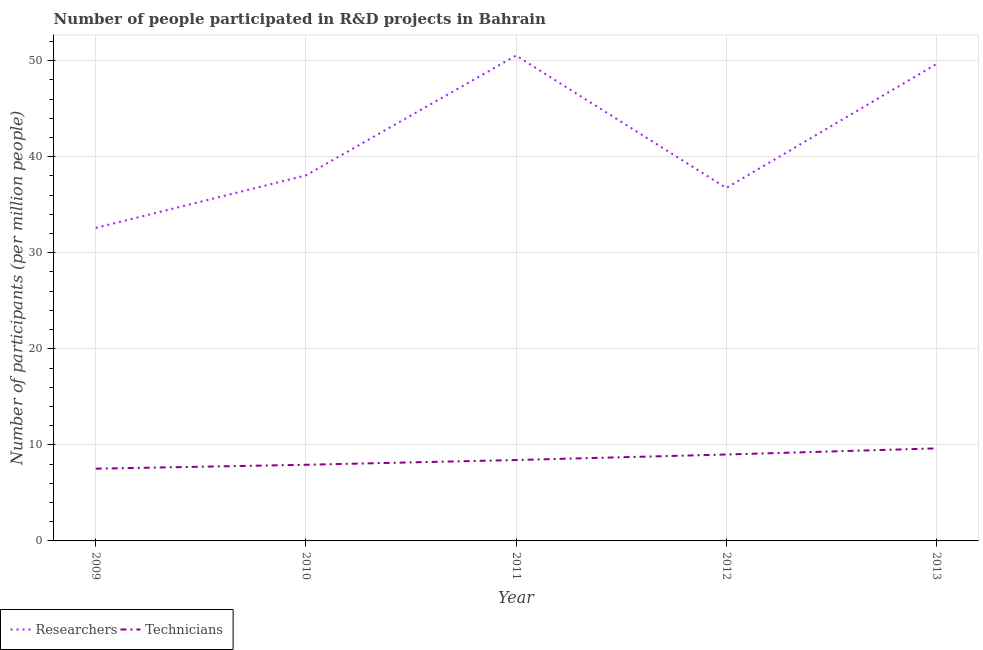How many different coloured lines are there?
Keep it short and to the point. 2. Is the number of lines equal to the number of legend labels?
Offer a very short reply. Yes. What is the number of researchers in 2011?
Keep it short and to the point. 50.54. Across all years, what is the maximum number of researchers?
Offer a terse response. 50.54. Across all years, what is the minimum number of researchers?
Make the answer very short. 32.59. What is the total number of researchers in the graph?
Keep it short and to the point. 207.57. What is the difference between the number of technicians in 2009 and that in 2011?
Provide a succinct answer. -0.9. What is the difference between the number of researchers in 2010 and the number of technicians in 2009?
Your answer should be compact. 30.54. What is the average number of technicians per year?
Offer a very short reply. 8.5. In the year 2013, what is the difference between the number of researchers and number of technicians?
Your answer should be compact. 40.02. In how many years, is the number of technicians greater than 40?
Offer a terse response. 0. What is the ratio of the number of researchers in 2009 to that in 2011?
Ensure brevity in your answer.  0.64. Is the difference between the number of technicians in 2009 and 2012 greater than the difference between the number of researchers in 2009 and 2012?
Offer a very short reply. Yes. What is the difference between the highest and the second highest number of technicians?
Provide a short and direct response. 0.64. What is the difference between the highest and the lowest number of researchers?
Provide a succinct answer. 17.95. In how many years, is the number of technicians greater than the average number of technicians taken over all years?
Your response must be concise. 2. Does the number of researchers monotonically increase over the years?
Provide a short and direct response. No. Is the number of researchers strictly greater than the number of technicians over the years?
Provide a short and direct response. Yes. Is the number of researchers strictly less than the number of technicians over the years?
Provide a succinct answer. No. What is the difference between two consecutive major ticks on the Y-axis?
Your answer should be very brief. 10. Are the values on the major ticks of Y-axis written in scientific E-notation?
Provide a succinct answer. No. Does the graph contain any zero values?
Provide a succinct answer. No. Does the graph contain grids?
Your answer should be compact. Yes. How are the legend labels stacked?
Make the answer very short. Horizontal. What is the title of the graph?
Offer a terse response. Number of people participated in R&D projects in Bahrain. Does "Goods" appear as one of the legend labels in the graph?
Your response must be concise. No. What is the label or title of the Y-axis?
Give a very brief answer. Number of participants (per million people). What is the Number of participants (per million people) of Researchers in 2009?
Provide a succinct answer. 32.59. What is the Number of participants (per million people) of Technicians in 2009?
Provide a short and direct response. 7.52. What is the Number of participants (per million people) of Researchers in 2010?
Ensure brevity in your answer.  38.06. What is the Number of participants (per million people) in Technicians in 2010?
Give a very brief answer. 7.93. What is the Number of participants (per million people) in Researchers in 2011?
Offer a very short reply. 50.54. What is the Number of participants (per million people) in Technicians in 2011?
Make the answer very short. 8.42. What is the Number of participants (per million people) of Researchers in 2012?
Offer a terse response. 36.74. What is the Number of participants (per million people) in Technicians in 2012?
Your response must be concise. 9. What is the Number of participants (per million people) in Researchers in 2013?
Ensure brevity in your answer.  49.65. What is the Number of participants (per million people) in Technicians in 2013?
Your response must be concise. 9.63. Across all years, what is the maximum Number of participants (per million people) in Researchers?
Give a very brief answer. 50.54. Across all years, what is the maximum Number of participants (per million people) in Technicians?
Provide a succinct answer. 9.63. Across all years, what is the minimum Number of participants (per million people) of Researchers?
Provide a short and direct response. 32.59. Across all years, what is the minimum Number of participants (per million people) in Technicians?
Provide a succinct answer. 7.52. What is the total Number of participants (per million people) of Researchers in the graph?
Your answer should be very brief. 207.57. What is the total Number of participants (per million people) in Technicians in the graph?
Your response must be concise. 42.5. What is the difference between the Number of participants (per million people) of Researchers in 2009 and that in 2010?
Ensure brevity in your answer.  -5.47. What is the difference between the Number of participants (per million people) of Technicians in 2009 and that in 2010?
Keep it short and to the point. -0.41. What is the difference between the Number of participants (per million people) of Researchers in 2009 and that in 2011?
Your answer should be very brief. -17.95. What is the difference between the Number of participants (per million people) in Technicians in 2009 and that in 2011?
Provide a short and direct response. -0.9. What is the difference between the Number of participants (per million people) in Researchers in 2009 and that in 2012?
Provide a succinct answer. -4.16. What is the difference between the Number of participants (per million people) in Technicians in 2009 and that in 2012?
Give a very brief answer. -1.48. What is the difference between the Number of participants (per million people) of Researchers in 2009 and that in 2013?
Ensure brevity in your answer.  -17.06. What is the difference between the Number of participants (per million people) of Technicians in 2009 and that in 2013?
Your answer should be compact. -2.11. What is the difference between the Number of participants (per million people) of Researchers in 2010 and that in 2011?
Give a very brief answer. -12.48. What is the difference between the Number of participants (per million people) of Technicians in 2010 and that in 2011?
Your response must be concise. -0.49. What is the difference between the Number of participants (per million people) of Researchers in 2010 and that in 2012?
Provide a succinct answer. 1.31. What is the difference between the Number of participants (per million people) of Technicians in 2010 and that in 2012?
Your response must be concise. -1.07. What is the difference between the Number of participants (per million people) in Researchers in 2010 and that in 2013?
Your response must be concise. -11.6. What is the difference between the Number of participants (per million people) of Technicians in 2010 and that in 2013?
Make the answer very short. -1.71. What is the difference between the Number of participants (per million people) of Researchers in 2011 and that in 2012?
Your answer should be compact. 13.79. What is the difference between the Number of participants (per million people) of Technicians in 2011 and that in 2012?
Make the answer very short. -0.58. What is the difference between the Number of participants (per million people) in Researchers in 2011 and that in 2013?
Your response must be concise. 0.88. What is the difference between the Number of participants (per million people) in Technicians in 2011 and that in 2013?
Give a very brief answer. -1.21. What is the difference between the Number of participants (per million people) of Researchers in 2012 and that in 2013?
Provide a short and direct response. -12.91. What is the difference between the Number of participants (per million people) in Technicians in 2012 and that in 2013?
Provide a short and direct response. -0.64. What is the difference between the Number of participants (per million people) of Researchers in 2009 and the Number of participants (per million people) of Technicians in 2010?
Your answer should be very brief. 24.66. What is the difference between the Number of participants (per million people) of Researchers in 2009 and the Number of participants (per million people) of Technicians in 2011?
Give a very brief answer. 24.16. What is the difference between the Number of participants (per million people) of Researchers in 2009 and the Number of participants (per million people) of Technicians in 2012?
Make the answer very short. 23.59. What is the difference between the Number of participants (per million people) of Researchers in 2009 and the Number of participants (per million people) of Technicians in 2013?
Your answer should be compact. 22.95. What is the difference between the Number of participants (per million people) in Researchers in 2010 and the Number of participants (per million people) in Technicians in 2011?
Give a very brief answer. 29.63. What is the difference between the Number of participants (per million people) of Researchers in 2010 and the Number of participants (per million people) of Technicians in 2012?
Provide a succinct answer. 29.06. What is the difference between the Number of participants (per million people) in Researchers in 2010 and the Number of participants (per million people) in Technicians in 2013?
Provide a succinct answer. 28.42. What is the difference between the Number of participants (per million people) in Researchers in 2011 and the Number of participants (per million people) in Technicians in 2012?
Your answer should be very brief. 41.54. What is the difference between the Number of participants (per million people) in Researchers in 2011 and the Number of participants (per million people) in Technicians in 2013?
Your response must be concise. 40.9. What is the difference between the Number of participants (per million people) of Researchers in 2012 and the Number of participants (per million people) of Technicians in 2013?
Your response must be concise. 27.11. What is the average Number of participants (per million people) of Researchers per year?
Offer a terse response. 41.51. What is the average Number of participants (per million people) in Technicians per year?
Keep it short and to the point. 8.5. In the year 2009, what is the difference between the Number of participants (per million people) in Researchers and Number of participants (per million people) in Technicians?
Provide a short and direct response. 25.07. In the year 2010, what is the difference between the Number of participants (per million people) of Researchers and Number of participants (per million people) of Technicians?
Your answer should be very brief. 30.13. In the year 2011, what is the difference between the Number of participants (per million people) in Researchers and Number of participants (per million people) in Technicians?
Provide a short and direct response. 42.11. In the year 2012, what is the difference between the Number of participants (per million people) of Researchers and Number of participants (per million people) of Technicians?
Your response must be concise. 27.74. In the year 2013, what is the difference between the Number of participants (per million people) of Researchers and Number of participants (per million people) of Technicians?
Keep it short and to the point. 40.02. What is the ratio of the Number of participants (per million people) of Researchers in 2009 to that in 2010?
Offer a terse response. 0.86. What is the ratio of the Number of participants (per million people) in Technicians in 2009 to that in 2010?
Your answer should be very brief. 0.95. What is the ratio of the Number of participants (per million people) of Researchers in 2009 to that in 2011?
Keep it short and to the point. 0.64. What is the ratio of the Number of participants (per million people) in Technicians in 2009 to that in 2011?
Offer a terse response. 0.89. What is the ratio of the Number of participants (per million people) of Researchers in 2009 to that in 2012?
Your answer should be very brief. 0.89. What is the ratio of the Number of participants (per million people) in Technicians in 2009 to that in 2012?
Your response must be concise. 0.84. What is the ratio of the Number of participants (per million people) of Researchers in 2009 to that in 2013?
Your answer should be very brief. 0.66. What is the ratio of the Number of participants (per million people) in Technicians in 2009 to that in 2013?
Provide a short and direct response. 0.78. What is the ratio of the Number of participants (per million people) of Researchers in 2010 to that in 2011?
Your answer should be compact. 0.75. What is the ratio of the Number of participants (per million people) of Technicians in 2010 to that in 2011?
Offer a terse response. 0.94. What is the ratio of the Number of participants (per million people) of Researchers in 2010 to that in 2012?
Give a very brief answer. 1.04. What is the ratio of the Number of participants (per million people) of Technicians in 2010 to that in 2012?
Keep it short and to the point. 0.88. What is the ratio of the Number of participants (per million people) in Researchers in 2010 to that in 2013?
Give a very brief answer. 0.77. What is the ratio of the Number of participants (per million people) of Technicians in 2010 to that in 2013?
Give a very brief answer. 0.82. What is the ratio of the Number of participants (per million people) of Researchers in 2011 to that in 2012?
Ensure brevity in your answer.  1.38. What is the ratio of the Number of participants (per million people) of Technicians in 2011 to that in 2012?
Offer a terse response. 0.94. What is the ratio of the Number of participants (per million people) in Researchers in 2011 to that in 2013?
Ensure brevity in your answer.  1.02. What is the ratio of the Number of participants (per million people) of Technicians in 2011 to that in 2013?
Offer a terse response. 0.87. What is the ratio of the Number of participants (per million people) of Researchers in 2012 to that in 2013?
Provide a succinct answer. 0.74. What is the ratio of the Number of participants (per million people) in Technicians in 2012 to that in 2013?
Your response must be concise. 0.93. What is the difference between the highest and the second highest Number of participants (per million people) in Researchers?
Provide a succinct answer. 0.88. What is the difference between the highest and the second highest Number of participants (per million people) of Technicians?
Ensure brevity in your answer.  0.64. What is the difference between the highest and the lowest Number of participants (per million people) of Researchers?
Offer a very short reply. 17.95. What is the difference between the highest and the lowest Number of participants (per million people) of Technicians?
Ensure brevity in your answer.  2.11. 